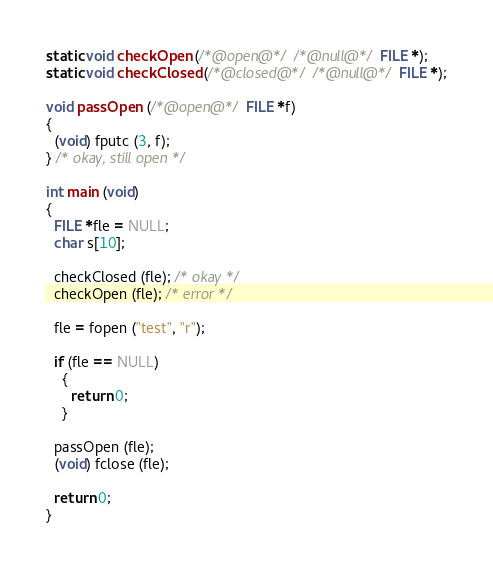<code> <loc_0><loc_0><loc_500><loc_500><_C_>static void checkOpen (/*@open@*/ /*@null@*/ FILE *);
static void checkClosed (/*@closed@*/ /*@null@*/ FILE *);

void passOpen (/*@open@*/ FILE *f)
{
  (void) fputc (3, f);
} /* okay, still open */

int main (void)
{
  FILE *fle = NULL;
  char s[10];

  checkClosed (fle); /* okay */
  checkOpen (fle); /* error */

  fle = fopen ("test", "r");

  if (fle == NULL) 
    {
      return 0;
    }

  passOpen (fle);
  (void) fclose (fle);

  return 0; 
} 

</code> 